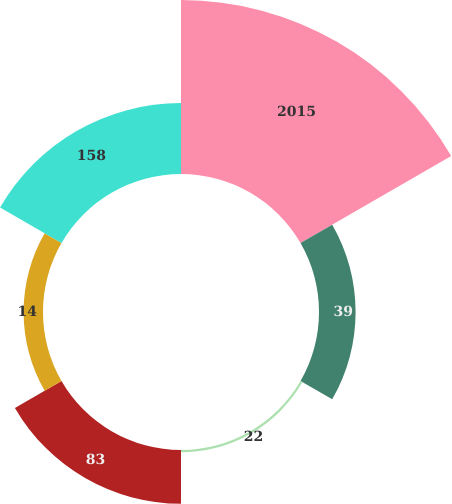<chart> <loc_0><loc_0><loc_500><loc_500><pie_chart><fcel>2015<fcel>39<fcel>22<fcel>83<fcel>14<fcel>158<nl><fcel>48.74%<fcel>10.25%<fcel>0.63%<fcel>15.06%<fcel>5.44%<fcel>19.87%<nl></chart> 